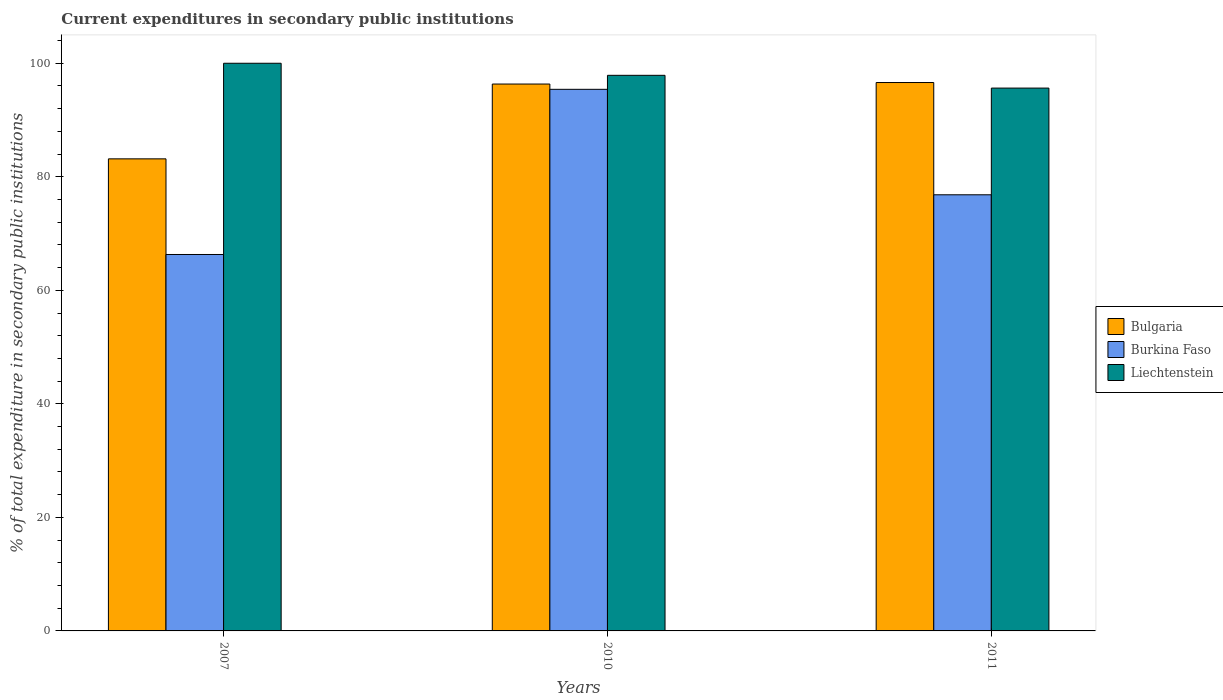How many groups of bars are there?
Provide a succinct answer. 3. How many bars are there on the 3rd tick from the left?
Your answer should be compact. 3. What is the current expenditures in secondary public institutions in Bulgaria in 2011?
Provide a succinct answer. 96.61. Across all years, what is the maximum current expenditures in secondary public institutions in Bulgaria?
Provide a succinct answer. 96.61. Across all years, what is the minimum current expenditures in secondary public institutions in Burkina Faso?
Ensure brevity in your answer.  66.31. In which year was the current expenditures in secondary public institutions in Burkina Faso maximum?
Make the answer very short. 2010. In which year was the current expenditures in secondary public institutions in Bulgaria minimum?
Your answer should be very brief. 2007. What is the total current expenditures in secondary public institutions in Burkina Faso in the graph?
Your response must be concise. 238.55. What is the difference between the current expenditures in secondary public institutions in Liechtenstein in 2007 and that in 2010?
Keep it short and to the point. 2.12. What is the difference between the current expenditures in secondary public institutions in Burkina Faso in 2011 and the current expenditures in secondary public institutions in Bulgaria in 2010?
Give a very brief answer. -19.51. What is the average current expenditures in secondary public institutions in Burkina Faso per year?
Provide a succinct answer. 79.52. In the year 2011, what is the difference between the current expenditures in secondary public institutions in Bulgaria and current expenditures in secondary public institutions in Liechtenstein?
Offer a terse response. 0.98. In how many years, is the current expenditures in secondary public institutions in Bulgaria greater than 4 %?
Offer a very short reply. 3. What is the ratio of the current expenditures in secondary public institutions in Liechtenstein in 2007 to that in 2010?
Your answer should be very brief. 1.02. Is the current expenditures in secondary public institutions in Liechtenstein in 2010 less than that in 2011?
Give a very brief answer. No. Is the difference between the current expenditures in secondary public institutions in Bulgaria in 2010 and 2011 greater than the difference between the current expenditures in secondary public institutions in Liechtenstein in 2010 and 2011?
Give a very brief answer. No. What is the difference between the highest and the second highest current expenditures in secondary public institutions in Bulgaria?
Offer a very short reply. 0.27. What is the difference between the highest and the lowest current expenditures in secondary public institutions in Bulgaria?
Your response must be concise. 13.45. In how many years, is the current expenditures in secondary public institutions in Burkina Faso greater than the average current expenditures in secondary public institutions in Burkina Faso taken over all years?
Your answer should be very brief. 1. What does the 2nd bar from the left in 2010 represents?
Offer a very short reply. Burkina Faso. What does the 2nd bar from the right in 2010 represents?
Your response must be concise. Burkina Faso. Is it the case that in every year, the sum of the current expenditures in secondary public institutions in Liechtenstein and current expenditures in secondary public institutions in Burkina Faso is greater than the current expenditures in secondary public institutions in Bulgaria?
Offer a very short reply. Yes. How many bars are there?
Give a very brief answer. 9. Are the values on the major ticks of Y-axis written in scientific E-notation?
Offer a very short reply. No. Does the graph contain grids?
Give a very brief answer. No. What is the title of the graph?
Keep it short and to the point. Current expenditures in secondary public institutions. Does "Austria" appear as one of the legend labels in the graph?
Your response must be concise. No. What is the label or title of the X-axis?
Give a very brief answer. Years. What is the label or title of the Y-axis?
Ensure brevity in your answer.  % of total expenditure in secondary public institutions. What is the % of total expenditure in secondary public institutions in Bulgaria in 2007?
Your answer should be very brief. 83.16. What is the % of total expenditure in secondary public institutions in Burkina Faso in 2007?
Give a very brief answer. 66.31. What is the % of total expenditure in secondary public institutions in Bulgaria in 2010?
Offer a very short reply. 96.34. What is the % of total expenditure in secondary public institutions in Burkina Faso in 2010?
Offer a terse response. 95.41. What is the % of total expenditure in secondary public institutions in Liechtenstein in 2010?
Make the answer very short. 97.88. What is the % of total expenditure in secondary public institutions of Bulgaria in 2011?
Offer a terse response. 96.61. What is the % of total expenditure in secondary public institutions in Burkina Faso in 2011?
Your response must be concise. 76.83. What is the % of total expenditure in secondary public institutions in Liechtenstein in 2011?
Give a very brief answer. 95.62. Across all years, what is the maximum % of total expenditure in secondary public institutions of Bulgaria?
Keep it short and to the point. 96.61. Across all years, what is the maximum % of total expenditure in secondary public institutions in Burkina Faso?
Provide a succinct answer. 95.41. Across all years, what is the maximum % of total expenditure in secondary public institutions of Liechtenstein?
Ensure brevity in your answer.  100. Across all years, what is the minimum % of total expenditure in secondary public institutions of Bulgaria?
Your response must be concise. 83.16. Across all years, what is the minimum % of total expenditure in secondary public institutions of Burkina Faso?
Your answer should be very brief. 66.31. Across all years, what is the minimum % of total expenditure in secondary public institutions in Liechtenstein?
Your answer should be compact. 95.62. What is the total % of total expenditure in secondary public institutions of Bulgaria in the graph?
Provide a short and direct response. 276.11. What is the total % of total expenditure in secondary public institutions in Burkina Faso in the graph?
Keep it short and to the point. 238.55. What is the total % of total expenditure in secondary public institutions in Liechtenstein in the graph?
Make the answer very short. 293.5. What is the difference between the % of total expenditure in secondary public institutions in Bulgaria in 2007 and that in 2010?
Offer a very short reply. -13.18. What is the difference between the % of total expenditure in secondary public institutions in Burkina Faso in 2007 and that in 2010?
Your answer should be compact. -29.1. What is the difference between the % of total expenditure in secondary public institutions of Liechtenstein in 2007 and that in 2010?
Provide a succinct answer. 2.12. What is the difference between the % of total expenditure in secondary public institutions of Bulgaria in 2007 and that in 2011?
Offer a terse response. -13.45. What is the difference between the % of total expenditure in secondary public institutions of Burkina Faso in 2007 and that in 2011?
Make the answer very short. -10.52. What is the difference between the % of total expenditure in secondary public institutions of Liechtenstein in 2007 and that in 2011?
Your answer should be compact. 4.38. What is the difference between the % of total expenditure in secondary public institutions in Bulgaria in 2010 and that in 2011?
Your response must be concise. -0.27. What is the difference between the % of total expenditure in secondary public institutions in Burkina Faso in 2010 and that in 2011?
Give a very brief answer. 18.58. What is the difference between the % of total expenditure in secondary public institutions of Liechtenstein in 2010 and that in 2011?
Provide a succinct answer. 2.25. What is the difference between the % of total expenditure in secondary public institutions of Bulgaria in 2007 and the % of total expenditure in secondary public institutions of Burkina Faso in 2010?
Give a very brief answer. -12.25. What is the difference between the % of total expenditure in secondary public institutions of Bulgaria in 2007 and the % of total expenditure in secondary public institutions of Liechtenstein in 2010?
Your answer should be very brief. -14.71. What is the difference between the % of total expenditure in secondary public institutions in Burkina Faso in 2007 and the % of total expenditure in secondary public institutions in Liechtenstein in 2010?
Your answer should be very brief. -31.56. What is the difference between the % of total expenditure in secondary public institutions of Bulgaria in 2007 and the % of total expenditure in secondary public institutions of Burkina Faso in 2011?
Provide a short and direct response. 6.33. What is the difference between the % of total expenditure in secondary public institutions in Bulgaria in 2007 and the % of total expenditure in secondary public institutions in Liechtenstein in 2011?
Ensure brevity in your answer.  -12.46. What is the difference between the % of total expenditure in secondary public institutions in Burkina Faso in 2007 and the % of total expenditure in secondary public institutions in Liechtenstein in 2011?
Offer a very short reply. -29.31. What is the difference between the % of total expenditure in secondary public institutions of Bulgaria in 2010 and the % of total expenditure in secondary public institutions of Burkina Faso in 2011?
Keep it short and to the point. 19.51. What is the difference between the % of total expenditure in secondary public institutions in Bulgaria in 2010 and the % of total expenditure in secondary public institutions in Liechtenstein in 2011?
Ensure brevity in your answer.  0.71. What is the difference between the % of total expenditure in secondary public institutions of Burkina Faso in 2010 and the % of total expenditure in secondary public institutions of Liechtenstein in 2011?
Offer a very short reply. -0.21. What is the average % of total expenditure in secondary public institutions in Bulgaria per year?
Your answer should be compact. 92.04. What is the average % of total expenditure in secondary public institutions in Burkina Faso per year?
Make the answer very short. 79.52. What is the average % of total expenditure in secondary public institutions of Liechtenstein per year?
Provide a succinct answer. 97.83. In the year 2007, what is the difference between the % of total expenditure in secondary public institutions in Bulgaria and % of total expenditure in secondary public institutions in Burkina Faso?
Make the answer very short. 16.85. In the year 2007, what is the difference between the % of total expenditure in secondary public institutions in Bulgaria and % of total expenditure in secondary public institutions in Liechtenstein?
Keep it short and to the point. -16.84. In the year 2007, what is the difference between the % of total expenditure in secondary public institutions of Burkina Faso and % of total expenditure in secondary public institutions of Liechtenstein?
Your answer should be compact. -33.69. In the year 2010, what is the difference between the % of total expenditure in secondary public institutions of Bulgaria and % of total expenditure in secondary public institutions of Burkina Faso?
Provide a short and direct response. 0.93. In the year 2010, what is the difference between the % of total expenditure in secondary public institutions in Bulgaria and % of total expenditure in secondary public institutions in Liechtenstein?
Your answer should be compact. -1.54. In the year 2010, what is the difference between the % of total expenditure in secondary public institutions of Burkina Faso and % of total expenditure in secondary public institutions of Liechtenstein?
Provide a short and direct response. -2.46. In the year 2011, what is the difference between the % of total expenditure in secondary public institutions of Bulgaria and % of total expenditure in secondary public institutions of Burkina Faso?
Offer a terse response. 19.78. In the year 2011, what is the difference between the % of total expenditure in secondary public institutions of Bulgaria and % of total expenditure in secondary public institutions of Liechtenstein?
Provide a succinct answer. 0.98. In the year 2011, what is the difference between the % of total expenditure in secondary public institutions of Burkina Faso and % of total expenditure in secondary public institutions of Liechtenstein?
Provide a succinct answer. -18.8. What is the ratio of the % of total expenditure in secondary public institutions in Bulgaria in 2007 to that in 2010?
Your response must be concise. 0.86. What is the ratio of the % of total expenditure in secondary public institutions in Burkina Faso in 2007 to that in 2010?
Offer a terse response. 0.69. What is the ratio of the % of total expenditure in secondary public institutions of Liechtenstein in 2007 to that in 2010?
Keep it short and to the point. 1.02. What is the ratio of the % of total expenditure in secondary public institutions in Bulgaria in 2007 to that in 2011?
Your answer should be compact. 0.86. What is the ratio of the % of total expenditure in secondary public institutions of Burkina Faso in 2007 to that in 2011?
Offer a terse response. 0.86. What is the ratio of the % of total expenditure in secondary public institutions in Liechtenstein in 2007 to that in 2011?
Keep it short and to the point. 1.05. What is the ratio of the % of total expenditure in secondary public institutions of Bulgaria in 2010 to that in 2011?
Your answer should be very brief. 1. What is the ratio of the % of total expenditure in secondary public institutions of Burkina Faso in 2010 to that in 2011?
Your answer should be very brief. 1.24. What is the ratio of the % of total expenditure in secondary public institutions in Liechtenstein in 2010 to that in 2011?
Give a very brief answer. 1.02. What is the difference between the highest and the second highest % of total expenditure in secondary public institutions in Bulgaria?
Your answer should be very brief. 0.27. What is the difference between the highest and the second highest % of total expenditure in secondary public institutions of Burkina Faso?
Keep it short and to the point. 18.58. What is the difference between the highest and the second highest % of total expenditure in secondary public institutions of Liechtenstein?
Your response must be concise. 2.12. What is the difference between the highest and the lowest % of total expenditure in secondary public institutions in Bulgaria?
Your response must be concise. 13.45. What is the difference between the highest and the lowest % of total expenditure in secondary public institutions in Burkina Faso?
Make the answer very short. 29.1. What is the difference between the highest and the lowest % of total expenditure in secondary public institutions of Liechtenstein?
Make the answer very short. 4.38. 